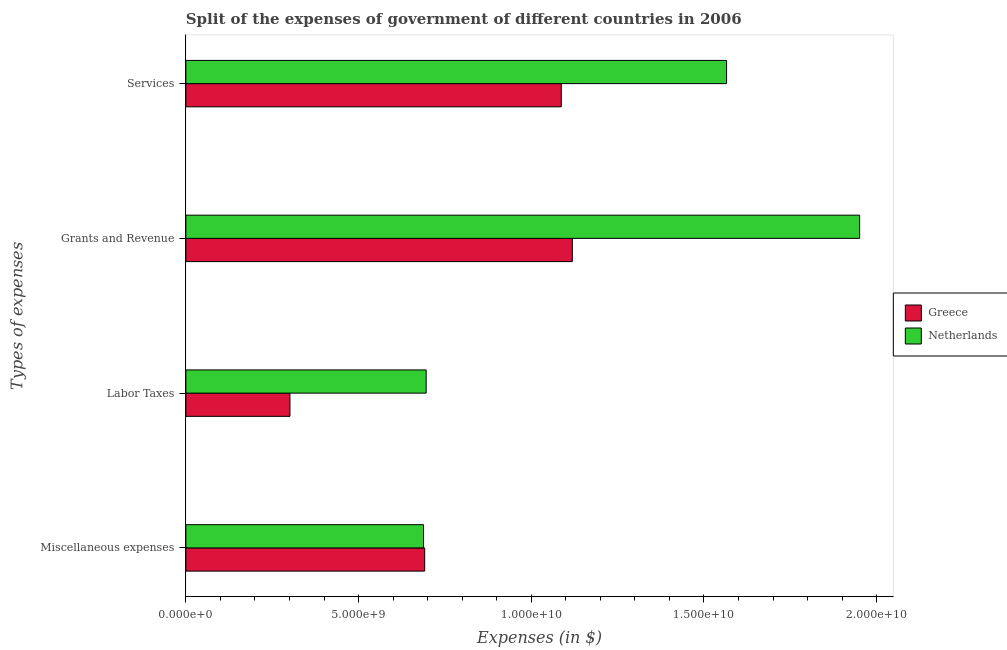How many different coloured bars are there?
Offer a terse response. 2. How many groups of bars are there?
Give a very brief answer. 4. Are the number of bars per tick equal to the number of legend labels?
Provide a succinct answer. Yes. Are the number of bars on each tick of the Y-axis equal?
Ensure brevity in your answer.  Yes. What is the label of the 2nd group of bars from the top?
Offer a terse response. Grants and Revenue. What is the amount spent on services in Netherlands?
Provide a succinct answer. 1.57e+1. Across all countries, what is the maximum amount spent on grants and revenue?
Your answer should be compact. 1.95e+1. Across all countries, what is the minimum amount spent on services?
Your response must be concise. 1.09e+1. What is the total amount spent on labor taxes in the graph?
Offer a very short reply. 9.97e+09. What is the difference between the amount spent on grants and revenue in Greece and that in Netherlands?
Provide a succinct answer. -8.32e+09. What is the difference between the amount spent on grants and revenue in Greece and the amount spent on miscellaneous expenses in Netherlands?
Offer a terse response. 4.31e+09. What is the average amount spent on labor taxes per country?
Your answer should be very brief. 4.98e+09. What is the difference between the amount spent on services and amount spent on grants and revenue in Greece?
Provide a short and direct response. -3.19e+08. In how many countries, is the amount spent on miscellaneous expenses greater than 2000000000 $?
Provide a succinct answer. 2. What is the ratio of the amount spent on services in Greece to that in Netherlands?
Make the answer very short. 0.69. What is the difference between the highest and the second highest amount spent on labor taxes?
Your answer should be very brief. 3.94e+09. What is the difference between the highest and the lowest amount spent on grants and revenue?
Offer a very short reply. 8.32e+09. In how many countries, is the amount spent on services greater than the average amount spent on services taken over all countries?
Give a very brief answer. 1. Is it the case that in every country, the sum of the amount spent on grants and revenue and amount spent on services is greater than the sum of amount spent on miscellaneous expenses and amount spent on labor taxes?
Ensure brevity in your answer.  Yes. Is it the case that in every country, the sum of the amount spent on miscellaneous expenses and amount spent on labor taxes is greater than the amount spent on grants and revenue?
Keep it short and to the point. No. How many countries are there in the graph?
Your response must be concise. 2. Are the values on the major ticks of X-axis written in scientific E-notation?
Your answer should be very brief. Yes. Does the graph contain any zero values?
Offer a terse response. No. How are the legend labels stacked?
Keep it short and to the point. Vertical. What is the title of the graph?
Offer a terse response. Split of the expenses of government of different countries in 2006. Does "San Marino" appear as one of the legend labels in the graph?
Your answer should be very brief. No. What is the label or title of the X-axis?
Keep it short and to the point. Expenses (in $). What is the label or title of the Y-axis?
Your response must be concise. Types of expenses. What is the Expenses (in $) in Greece in Miscellaneous expenses?
Provide a short and direct response. 6.91e+09. What is the Expenses (in $) of Netherlands in Miscellaneous expenses?
Make the answer very short. 6.88e+09. What is the Expenses (in $) of Greece in Labor Taxes?
Give a very brief answer. 3.01e+09. What is the Expenses (in $) of Netherlands in Labor Taxes?
Keep it short and to the point. 6.96e+09. What is the Expenses (in $) of Greece in Grants and Revenue?
Offer a very short reply. 1.12e+1. What is the Expenses (in $) in Netherlands in Grants and Revenue?
Your answer should be very brief. 1.95e+1. What is the Expenses (in $) in Greece in Services?
Provide a short and direct response. 1.09e+1. What is the Expenses (in $) of Netherlands in Services?
Make the answer very short. 1.57e+1. Across all Types of expenses, what is the maximum Expenses (in $) of Greece?
Provide a succinct answer. 1.12e+1. Across all Types of expenses, what is the maximum Expenses (in $) of Netherlands?
Provide a short and direct response. 1.95e+1. Across all Types of expenses, what is the minimum Expenses (in $) in Greece?
Provide a short and direct response. 3.01e+09. Across all Types of expenses, what is the minimum Expenses (in $) of Netherlands?
Offer a very short reply. 6.88e+09. What is the total Expenses (in $) of Greece in the graph?
Your response must be concise. 3.20e+1. What is the total Expenses (in $) of Netherlands in the graph?
Provide a short and direct response. 4.90e+1. What is the difference between the Expenses (in $) in Greece in Miscellaneous expenses and that in Labor Taxes?
Provide a short and direct response. 3.90e+09. What is the difference between the Expenses (in $) in Netherlands in Miscellaneous expenses and that in Labor Taxes?
Your response must be concise. -7.70e+07. What is the difference between the Expenses (in $) in Greece in Miscellaneous expenses and that in Grants and Revenue?
Provide a succinct answer. -4.27e+09. What is the difference between the Expenses (in $) in Netherlands in Miscellaneous expenses and that in Grants and Revenue?
Your response must be concise. -1.26e+1. What is the difference between the Expenses (in $) of Greece in Miscellaneous expenses and that in Services?
Ensure brevity in your answer.  -3.96e+09. What is the difference between the Expenses (in $) of Netherlands in Miscellaneous expenses and that in Services?
Keep it short and to the point. -8.77e+09. What is the difference between the Expenses (in $) of Greece in Labor Taxes and that in Grants and Revenue?
Your answer should be very brief. -8.18e+09. What is the difference between the Expenses (in $) in Netherlands in Labor Taxes and that in Grants and Revenue?
Your answer should be compact. -1.25e+1. What is the difference between the Expenses (in $) in Greece in Labor Taxes and that in Services?
Offer a terse response. -7.86e+09. What is the difference between the Expenses (in $) in Netherlands in Labor Taxes and that in Services?
Make the answer very short. -8.70e+09. What is the difference between the Expenses (in $) in Greece in Grants and Revenue and that in Services?
Your answer should be compact. 3.19e+08. What is the difference between the Expenses (in $) in Netherlands in Grants and Revenue and that in Services?
Offer a very short reply. 3.85e+09. What is the difference between the Expenses (in $) of Greece in Miscellaneous expenses and the Expenses (in $) of Netherlands in Labor Taxes?
Give a very brief answer. -4.30e+07. What is the difference between the Expenses (in $) in Greece in Miscellaneous expenses and the Expenses (in $) in Netherlands in Grants and Revenue?
Ensure brevity in your answer.  -1.26e+1. What is the difference between the Expenses (in $) of Greece in Miscellaneous expenses and the Expenses (in $) of Netherlands in Services?
Your response must be concise. -8.74e+09. What is the difference between the Expenses (in $) of Greece in Labor Taxes and the Expenses (in $) of Netherlands in Grants and Revenue?
Provide a succinct answer. -1.65e+1. What is the difference between the Expenses (in $) of Greece in Labor Taxes and the Expenses (in $) of Netherlands in Services?
Your response must be concise. -1.26e+1. What is the difference between the Expenses (in $) in Greece in Grants and Revenue and the Expenses (in $) in Netherlands in Services?
Provide a short and direct response. -4.47e+09. What is the average Expenses (in $) of Greece per Types of expenses?
Provide a short and direct response. 8.00e+09. What is the average Expenses (in $) of Netherlands per Types of expenses?
Your answer should be compact. 1.22e+1. What is the difference between the Expenses (in $) of Greece and Expenses (in $) of Netherlands in Miscellaneous expenses?
Make the answer very short. 3.40e+07. What is the difference between the Expenses (in $) in Greece and Expenses (in $) in Netherlands in Labor Taxes?
Your answer should be compact. -3.94e+09. What is the difference between the Expenses (in $) of Greece and Expenses (in $) of Netherlands in Grants and Revenue?
Your answer should be compact. -8.32e+09. What is the difference between the Expenses (in $) of Greece and Expenses (in $) of Netherlands in Services?
Your response must be concise. -4.78e+09. What is the ratio of the Expenses (in $) in Greece in Miscellaneous expenses to that in Labor Taxes?
Provide a succinct answer. 2.29. What is the ratio of the Expenses (in $) of Netherlands in Miscellaneous expenses to that in Labor Taxes?
Give a very brief answer. 0.99. What is the ratio of the Expenses (in $) of Greece in Miscellaneous expenses to that in Grants and Revenue?
Provide a short and direct response. 0.62. What is the ratio of the Expenses (in $) of Netherlands in Miscellaneous expenses to that in Grants and Revenue?
Offer a terse response. 0.35. What is the ratio of the Expenses (in $) in Greece in Miscellaneous expenses to that in Services?
Give a very brief answer. 0.64. What is the ratio of the Expenses (in $) of Netherlands in Miscellaneous expenses to that in Services?
Ensure brevity in your answer.  0.44. What is the ratio of the Expenses (in $) of Greece in Labor Taxes to that in Grants and Revenue?
Ensure brevity in your answer.  0.27. What is the ratio of the Expenses (in $) in Netherlands in Labor Taxes to that in Grants and Revenue?
Ensure brevity in your answer.  0.36. What is the ratio of the Expenses (in $) of Greece in Labor Taxes to that in Services?
Provide a short and direct response. 0.28. What is the ratio of the Expenses (in $) in Netherlands in Labor Taxes to that in Services?
Make the answer very short. 0.44. What is the ratio of the Expenses (in $) in Greece in Grants and Revenue to that in Services?
Provide a succinct answer. 1.03. What is the ratio of the Expenses (in $) of Netherlands in Grants and Revenue to that in Services?
Your answer should be very brief. 1.25. What is the difference between the highest and the second highest Expenses (in $) in Greece?
Your answer should be compact. 3.19e+08. What is the difference between the highest and the second highest Expenses (in $) in Netherlands?
Give a very brief answer. 3.85e+09. What is the difference between the highest and the lowest Expenses (in $) of Greece?
Your answer should be compact. 8.18e+09. What is the difference between the highest and the lowest Expenses (in $) in Netherlands?
Make the answer very short. 1.26e+1. 